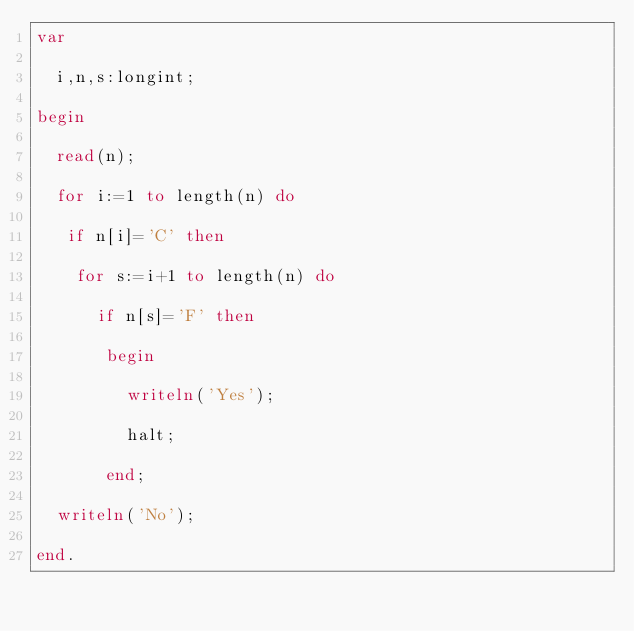<code> <loc_0><loc_0><loc_500><loc_500><_Pascal_>var

  i,n,s:longint;

begin
 
  read(n);
 
  for i:=1 to length(n) do
  
   if n[i]='C' then 
  
    for s:=i+1 to length(n) do
  
      if n[s]='F' then 
     
       begin
       
         writeln('Yes');
       
         halt;
      
       end;
    
  writeln('No');

end.
</code> 